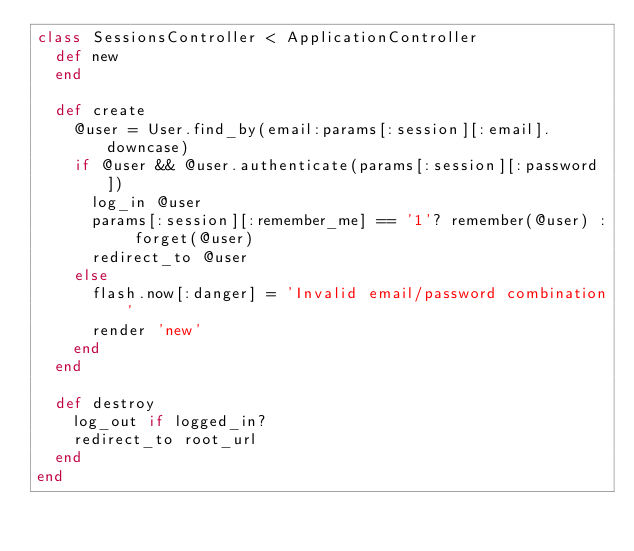Convert code to text. <code><loc_0><loc_0><loc_500><loc_500><_Ruby_>class SessionsController < ApplicationController
  def new
  end
  
  def create
    @user = User.find_by(email:params[:session][:email].downcase)
    if @user && @user.authenticate(params[:session][:password])
      log_in @user
      params[:session][:remember_me] == '1'? remember(@user) : forget(@user)
      redirect_to @user
    else
      flash.now[:danger] = 'Invalid email/password combination'
      render 'new'
    end
  end
  
  def destroy
    log_out if logged_in?
    redirect_to root_url
  end
end
</code> 